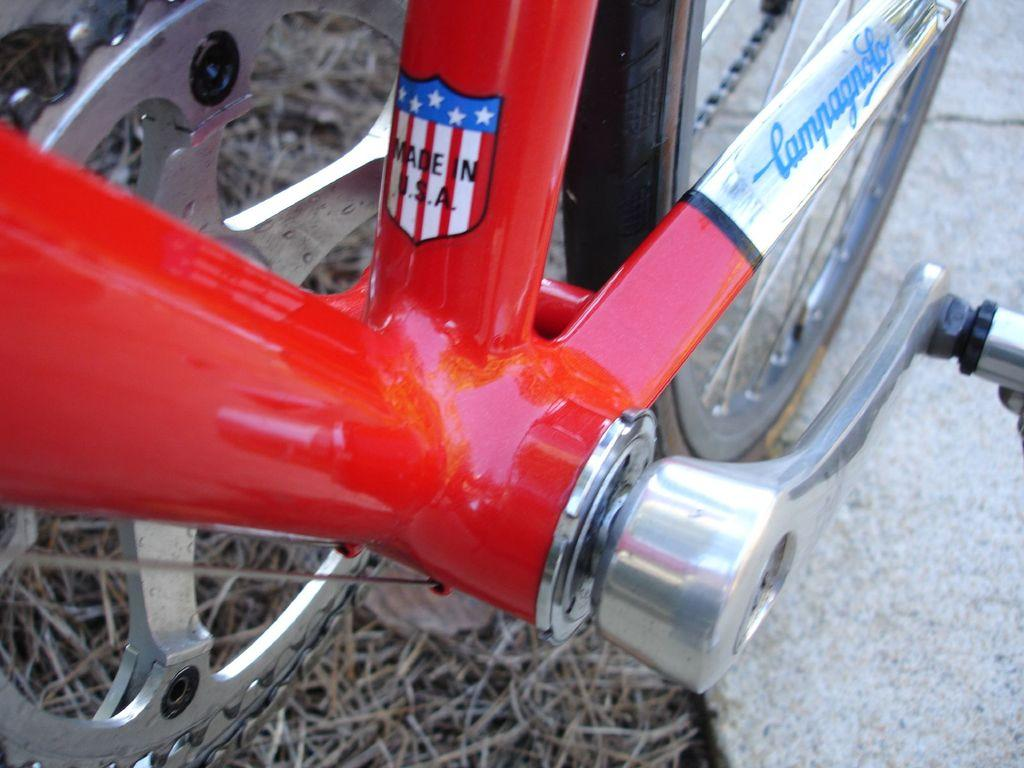What type of vehicle is partially visible in the image? There is a partial part of a bicycle in the image. How many eyes does the ant have in the image? There is no ant present in the image; it only features a partial part of a bicycle. 